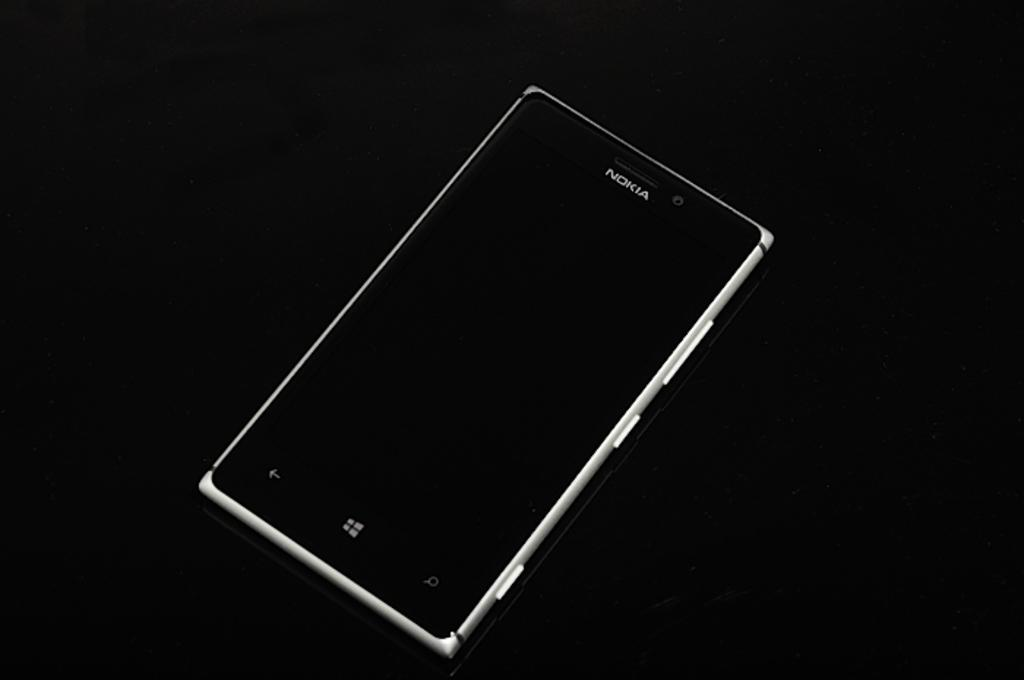<image>
Present a compact description of the photo's key features. Black Nokia cell phone on top of a black background. 